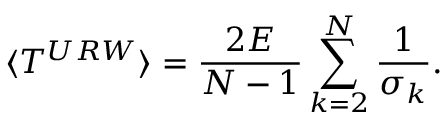<formula> <loc_0><loc_0><loc_500><loc_500>\langle T ^ { U R W } \rangle = \frac { 2 E } { N - 1 } \sum _ { k = 2 } ^ { N } \frac { 1 } { \sigma _ { k } } .</formula> 